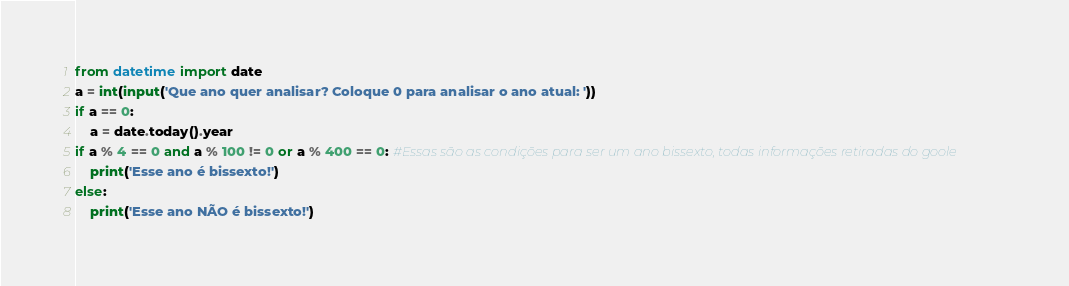Convert code to text. <code><loc_0><loc_0><loc_500><loc_500><_Python_>from datetime import date
a = int(input('Que ano quer analisar? Coloque 0 para analisar o ano atual: '))
if a == 0:
    a = date.today().year
if a % 4 == 0 and a % 100 != 0 or a % 400 == 0: #Essas são as condições para ser um ano bissexto, todas informações retiradas do goole
    print('Esse ano é bissexto!')
else:
    print('Esse ano NÃO é bissexto!')
</code> 